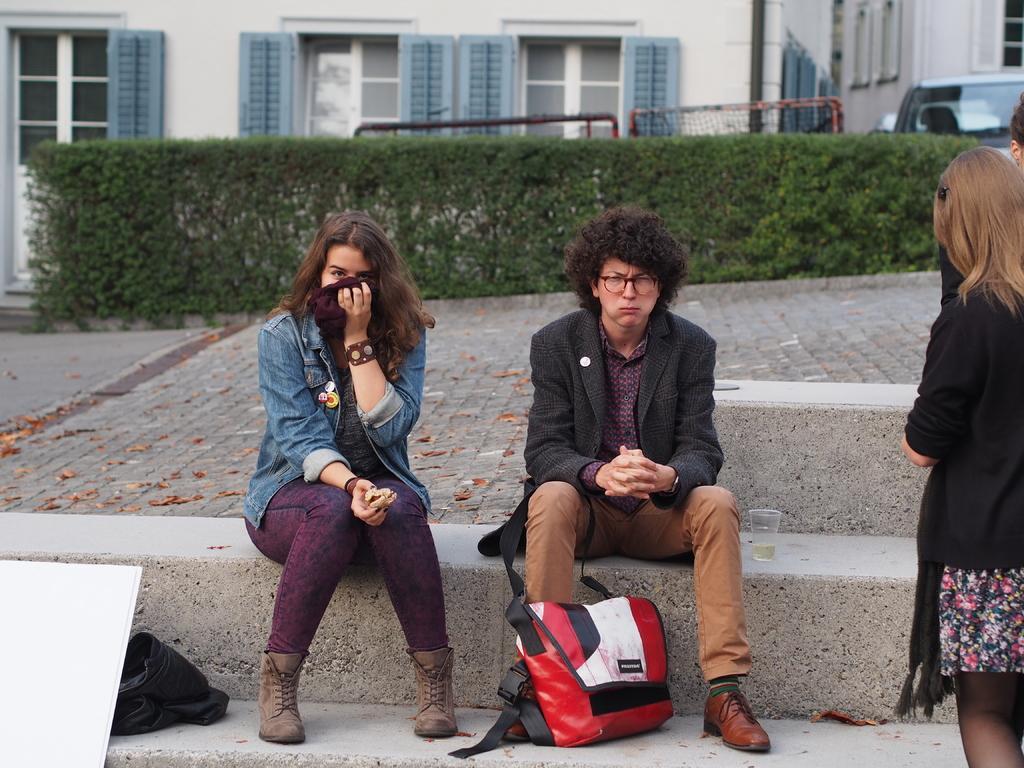Can you describe this image briefly? In the image there is a woman in jacket and a man in coat sitting on steps with a bag in front of him, on the right side there are two persons standing and in the back there is a building with plants and cars in front of it. 